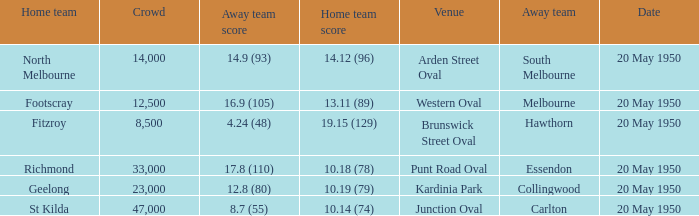What was the score for the away team when the home team was Fitzroy? 4.24 (48). 